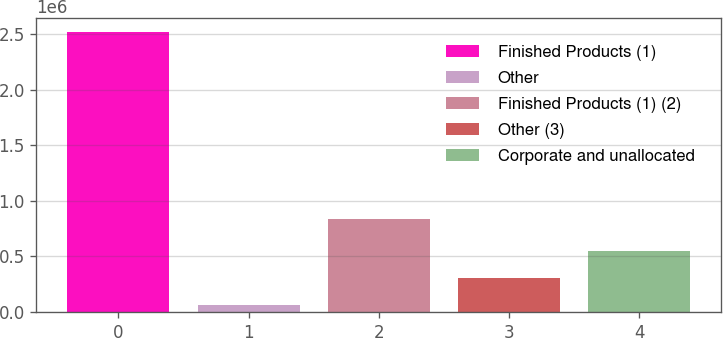Convert chart to OTSL. <chart><loc_0><loc_0><loc_500><loc_500><bar_chart><fcel>Finished Products (1)<fcel>Other<fcel>Finished Products (1) (2)<fcel>Other (3)<fcel>Corporate and unallocated<nl><fcel>2.5185e+06<fcel>60777<fcel>836053<fcel>306550<fcel>552323<nl></chart> 